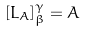Convert formula to latex. <formula><loc_0><loc_0><loc_500><loc_500>[ L _ { A } ] _ { \beta } ^ { \gamma } = A</formula> 